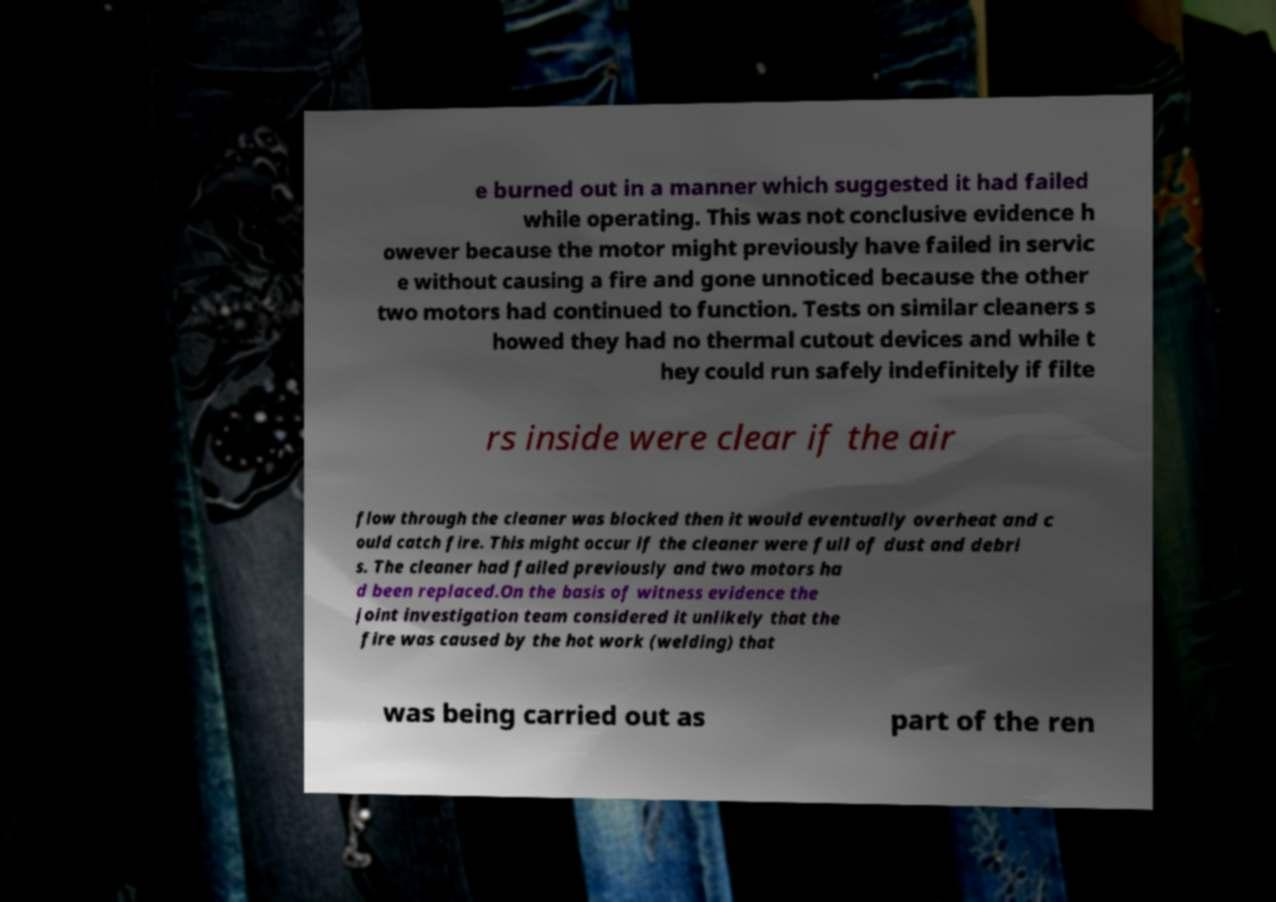Please read and relay the text visible in this image. What does it say? e burned out in a manner which suggested it had failed while operating. This was not conclusive evidence h owever because the motor might previously have failed in servic e without causing a fire and gone unnoticed because the other two motors had continued to function. Tests on similar cleaners s howed they had no thermal cutout devices and while t hey could run safely indefinitely if filte rs inside were clear if the air flow through the cleaner was blocked then it would eventually overheat and c ould catch fire. This might occur if the cleaner were full of dust and debri s. The cleaner had failed previously and two motors ha d been replaced.On the basis of witness evidence the joint investigation team considered it unlikely that the fire was caused by the hot work (welding) that was being carried out as part of the ren 